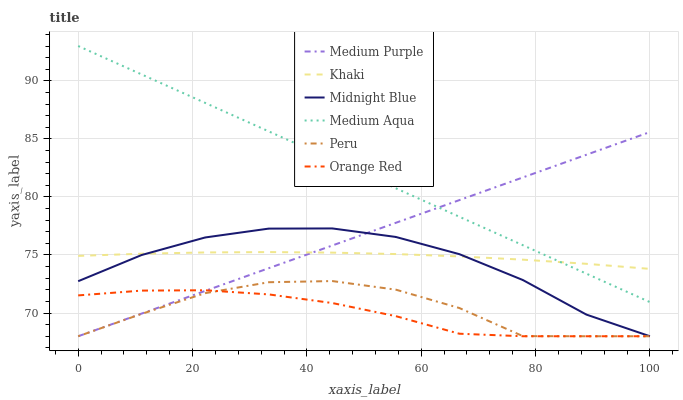Does Orange Red have the minimum area under the curve?
Answer yes or no. Yes. Does Medium Aqua have the maximum area under the curve?
Answer yes or no. Yes. Does Midnight Blue have the minimum area under the curve?
Answer yes or no. No. Does Midnight Blue have the maximum area under the curve?
Answer yes or no. No. Is Medium Aqua the smoothest?
Answer yes or no. Yes. Is Peru the roughest?
Answer yes or no. Yes. Is Midnight Blue the smoothest?
Answer yes or no. No. Is Midnight Blue the roughest?
Answer yes or no. No. Does Medium Aqua have the lowest value?
Answer yes or no. No. Does Midnight Blue have the highest value?
Answer yes or no. No. Is Orange Red less than Medium Aqua?
Answer yes or no. Yes. Is Medium Aqua greater than Peru?
Answer yes or no. Yes. Does Orange Red intersect Medium Aqua?
Answer yes or no. No. 